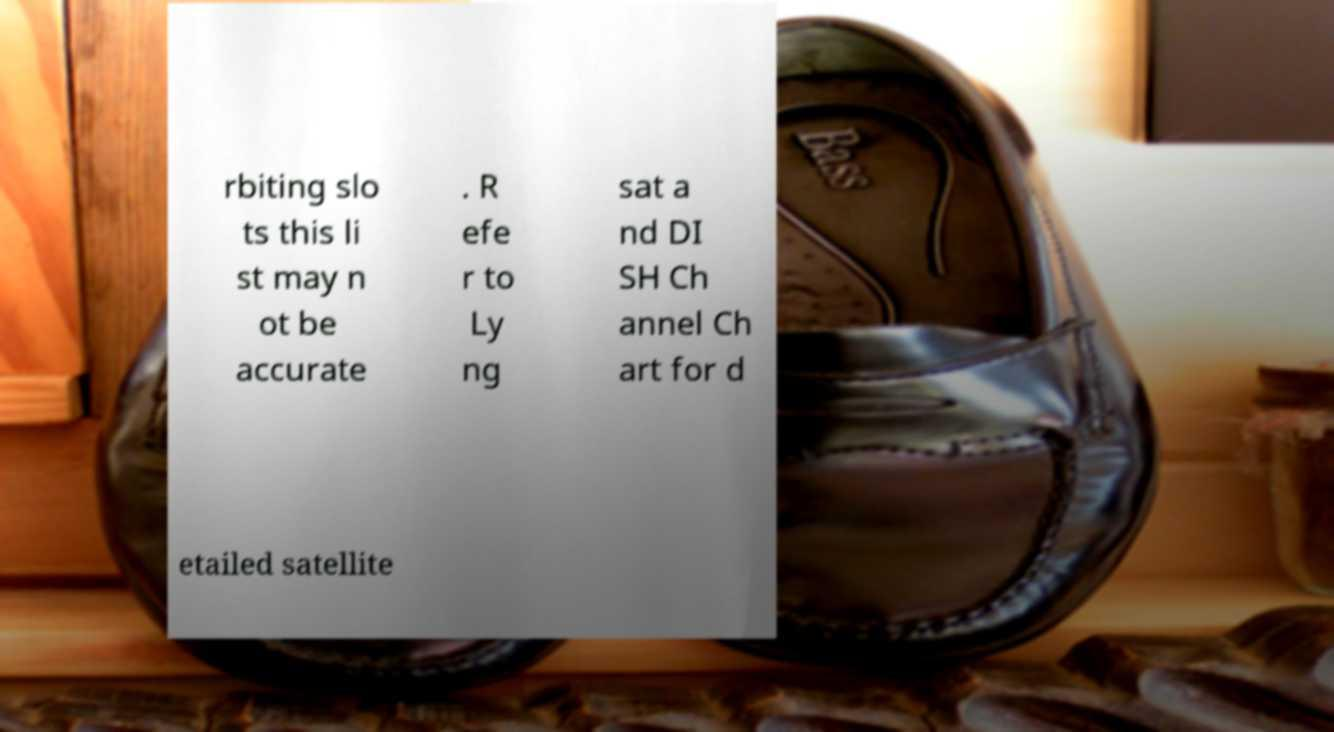What messages or text are displayed in this image? I need them in a readable, typed format. rbiting slo ts this li st may n ot be accurate . R efe r to Ly ng sat a nd DI SH Ch annel Ch art for d etailed satellite 